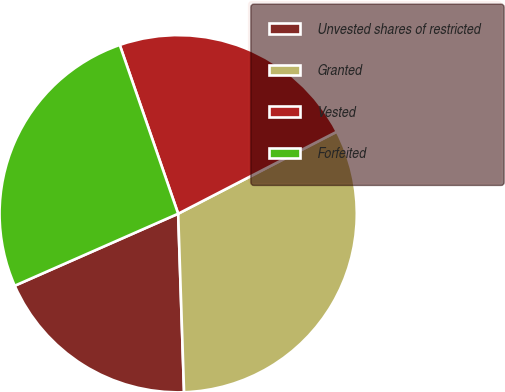Convert chart. <chart><loc_0><loc_0><loc_500><loc_500><pie_chart><fcel>Unvested shares of restricted<fcel>Granted<fcel>Vested<fcel>Forfeited<nl><fcel>18.92%<fcel>32.07%<fcel>22.71%<fcel>26.3%<nl></chart> 